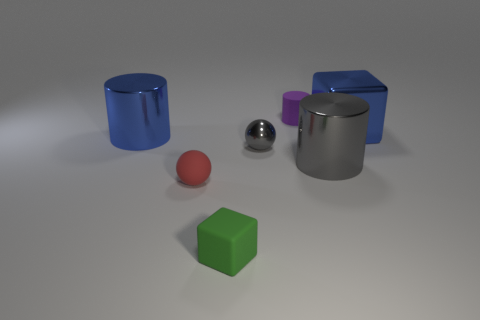Is there a big gray cube that has the same material as the tiny gray ball?
Provide a short and direct response. No. There is a metal cylinder that is the same color as the small shiny sphere; what is its size?
Your answer should be very brief. Large. What number of balls are either tiny red rubber things or tiny things?
Offer a terse response. 2. Is the number of big shiny cylinders to the right of the tiny gray metal thing greater than the number of tiny gray metallic objects that are on the right side of the blue metal cube?
Your answer should be compact. Yes. What number of tiny objects are the same color as the metal cube?
Offer a terse response. 0. There is a red sphere that is the same material as the small block; what is its size?
Make the answer very short. Small. How many things are balls that are right of the tiny green matte cube or big brown objects?
Make the answer very short. 1. Do the large metallic object on the left side of the gray shiny sphere and the small matte cube have the same color?
Your response must be concise. No. What is the size of the gray object that is the same shape as the red object?
Keep it short and to the point. Small. What color is the block in front of the rubber sphere that is to the left of the tiny matte object that is to the right of the small gray shiny thing?
Make the answer very short. Green. 